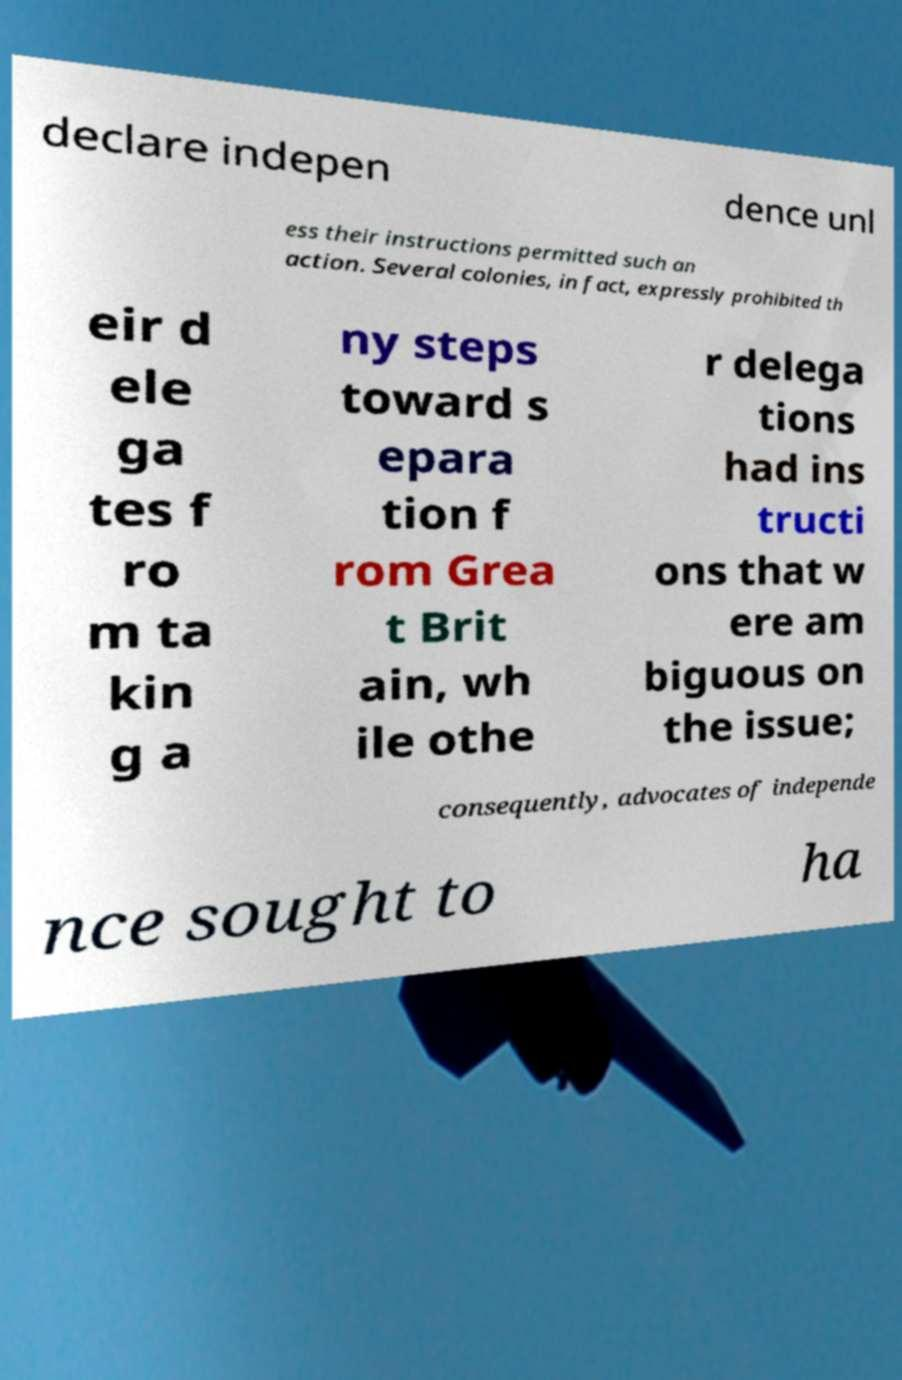Can you read and provide the text displayed in the image?This photo seems to have some interesting text. Can you extract and type it out for me? declare indepen dence unl ess their instructions permitted such an action. Several colonies, in fact, expressly prohibited th eir d ele ga tes f ro m ta kin g a ny steps toward s epara tion f rom Grea t Brit ain, wh ile othe r delega tions had ins tructi ons that w ere am biguous on the issue; consequently, advocates of independe nce sought to ha 